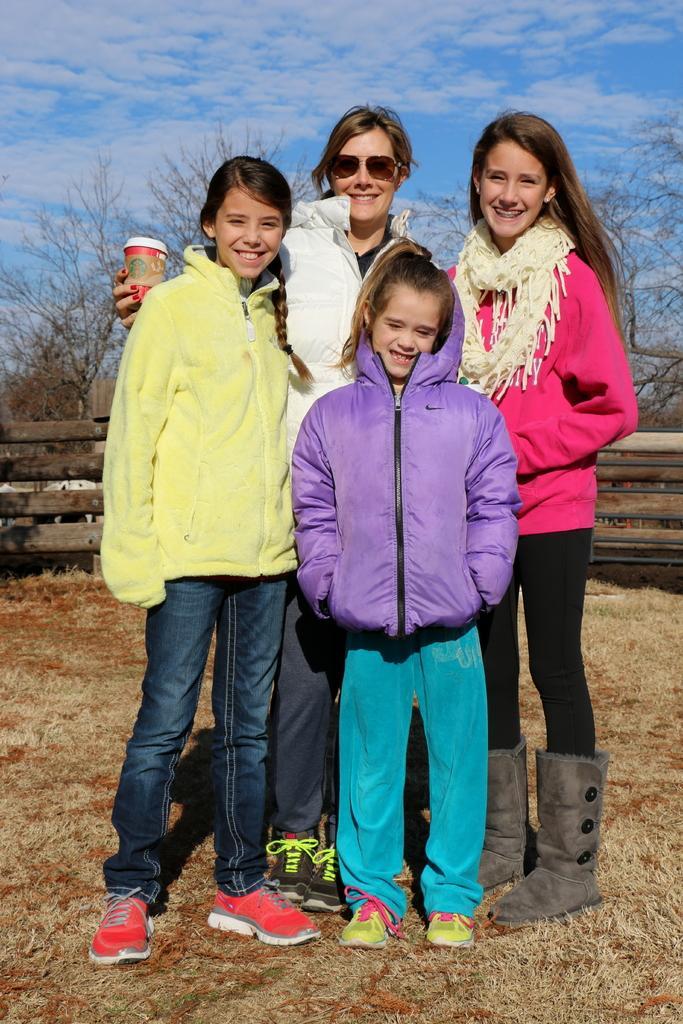Please provide a concise description of this image. In this image we can see few persons are standing on the ground and a woman is holding a cup in her hand. In the background we can see fence, trees and clouds in the sky. 